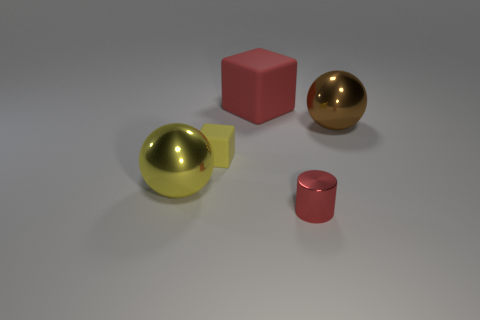Are there any red blocks that are in front of the shiny sphere right of the big rubber object? No, there are no red blocks in front of the shiny sphere. The red block on the left is situated behind the shiny sphere when viewed from this angle, and there are no other red blocks present in front of the sphere. 